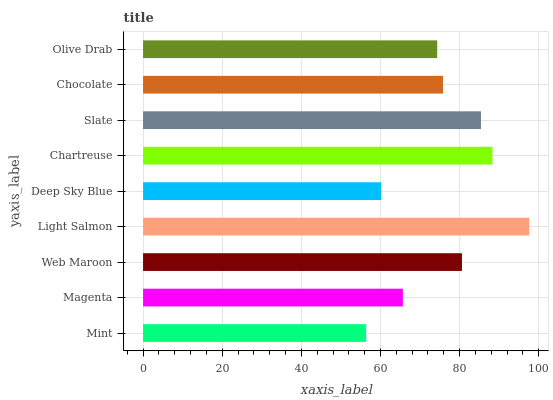Is Mint the minimum?
Answer yes or no. Yes. Is Light Salmon the maximum?
Answer yes or no. Yes. Is Magenta the minimum?
Answer yes or no. No. Is Magenta the maximum?
Answer yes or no. No. Is Magenta greater than Mint?
Answer yes or no. Yes. Is Mint less than Magenta?
Answer yes or no. Yes. Is Mint greater than Magenta?
Answer yes or no. No. Is Magenta less than Mint?
Answer yes or no. No. Is Chocolate the high median?
Answer yes or no. Yes. Is Chocolate the low median?
Answer yes or no. Yes. Is Mint the high median?
Answer yes or no. No. Is Chartreuse the low median?
Answer yes or no. No. 